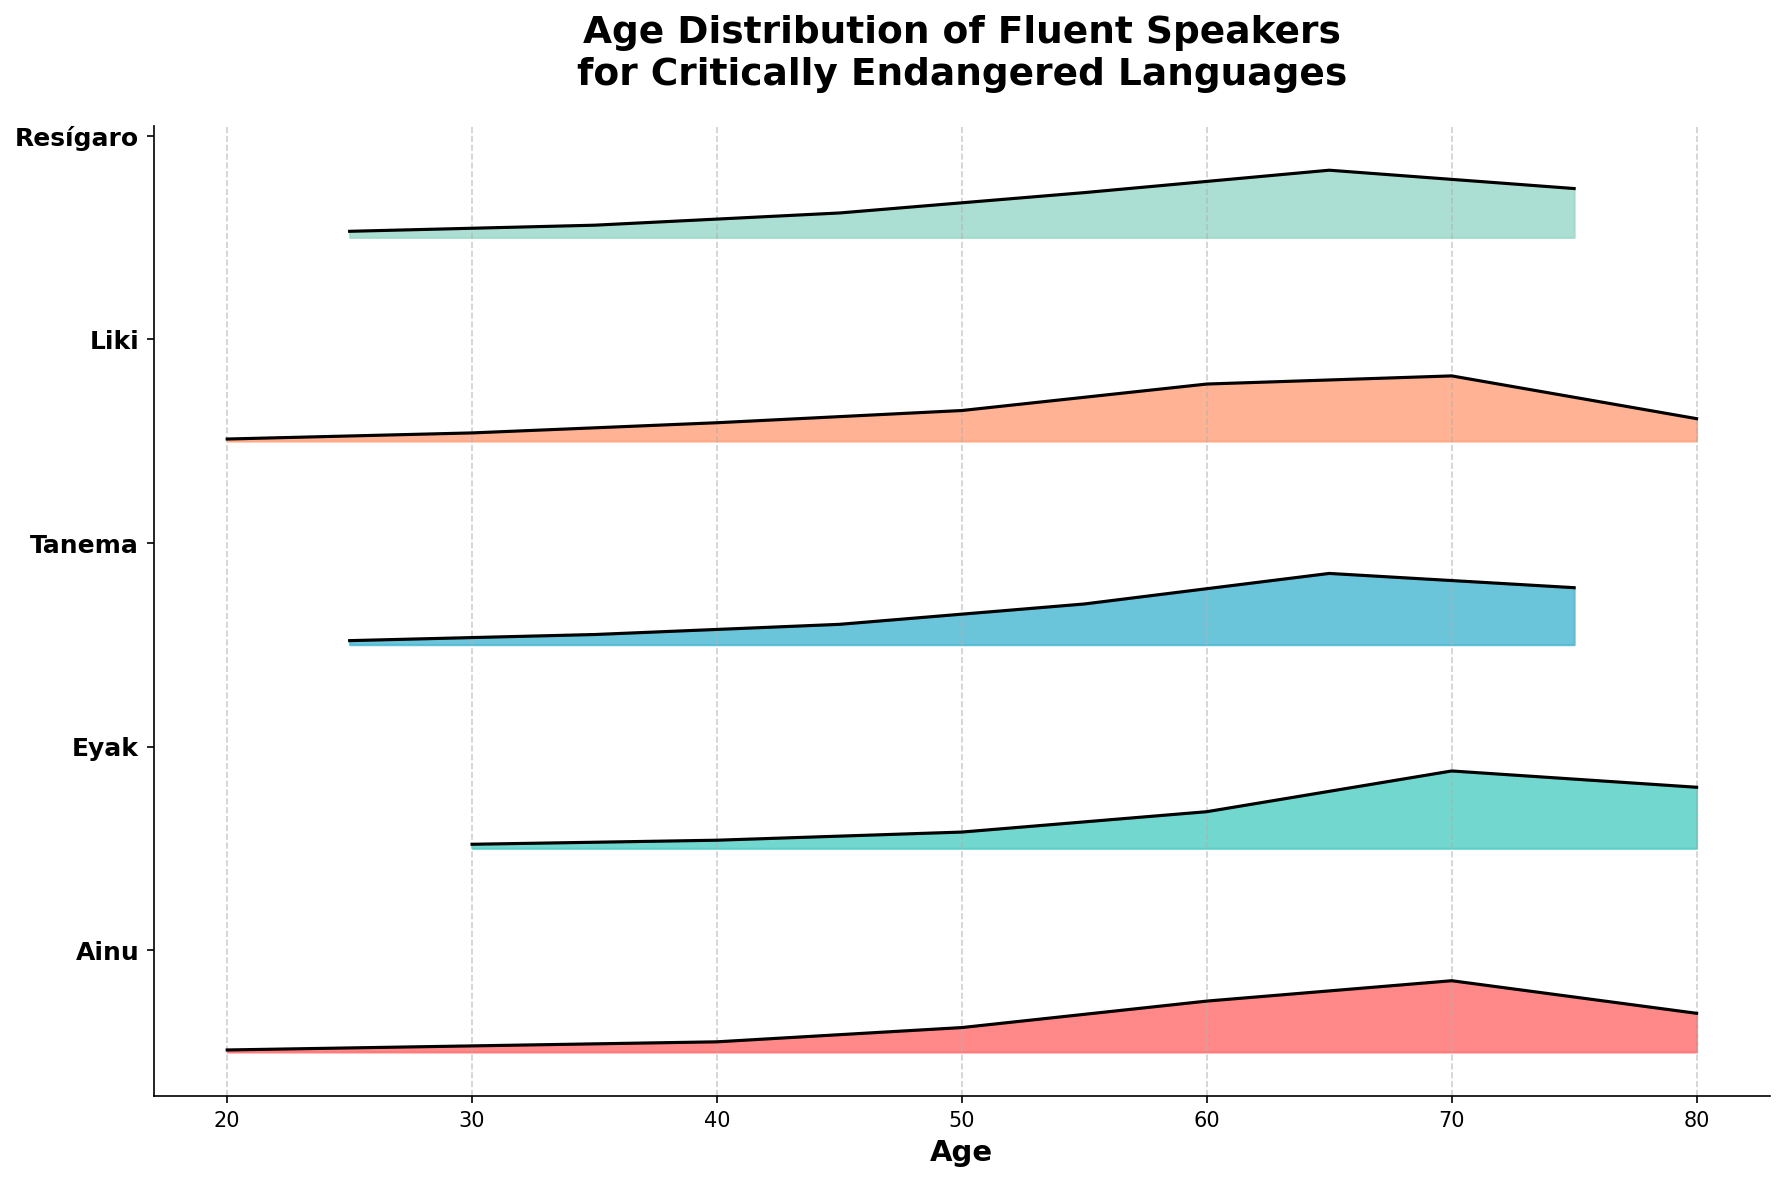What is the title of the plot? The title of the plot is written at the top of the figure and summarizes the main topic being visualized, which is "Age Distribution of Fluent Speakers for Critically Endangered Languages".
Answer: Age Distribution of Fluent Speakers for Critically Endangered Languages What is the x-axis label in the plot? The x-axis label is positioned below the horizontal axis and describes what is being measured on that axis, which is 'Age'.
Answer: Age How many languages are represented in the plot? By examining the y-axis labels, each unique label represents a different language, thus there are 5 languages: Ainu, Eyak, Tanema, Liki, and Resígaro.
Answer: 5 Which language has the highest density of speakers aged around 70? By looking at the density for age 70 for each language, the highest value can be identified. Ainu has the highest density at age 70 with a value of 0.35.
Answer: Ainu Which language shows a peak in speaker density between ages 55 and 65? Checking the density values between ages 55 and 65, Tanema has a peak of 0.35 at age 65.
Answer: Tanema Which language has a relatively high density of speakers above age 65? By examining the densities of speakers above age 65, Eyak has high densities of 0.38 at age 70 and 0.30 at age 80.
Answer: Eyak Compare the speaker densities of Resígaro and Liki at age 55. Which one is higher and by how much? Resígaro has a density of 0.22 while Liki has a density of 0.15 at age 55. The difference is 0.22 - 0.15 = 0.07. So, Resígaro is higher by 0.07.
Answer: Resígaro by 0.07 At what age does Ainu have the highest speaker density, and what is the value? By looking at the density values for Ainu, the peak can be identified as being at age 70 with a value of 0.35.
Answer: 70, 0.35 What is the overall trend in speaker density for Eyak language from age 30 to age 80? Eyak's density starts low at 0.02 at age 30, then steadily increases to 0.38 at age 70, peaking, and slightly dropping to 0.30 at age 80. It shows an increasing trend till 70, then  decreases.
Answer: Increasing till 70, then decreasing Which language has the lowest density of speakers below age 40? Checking the densities below age 40, Ainu has a density of 0.01 at age 20 and 0.03 at age 30 which are the lowest compared to other languages.
Answer: Ainu 